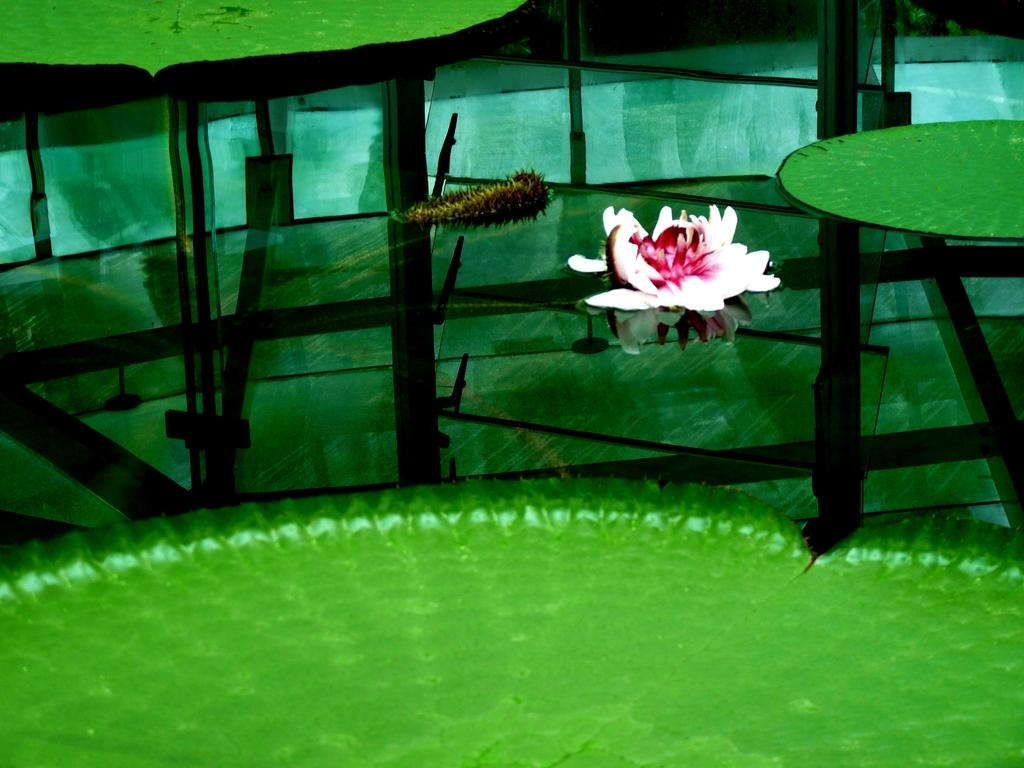What type of plant is in the image? There is a lotus in the image. What is the environment like in the image? There are leaves on the water in the image. What can be observed in the image due to the presence of water? There are reflections visible in the image. What type of flame can be seen flickering on the stove in the image? There is no flame, map, or stove present in the image. 